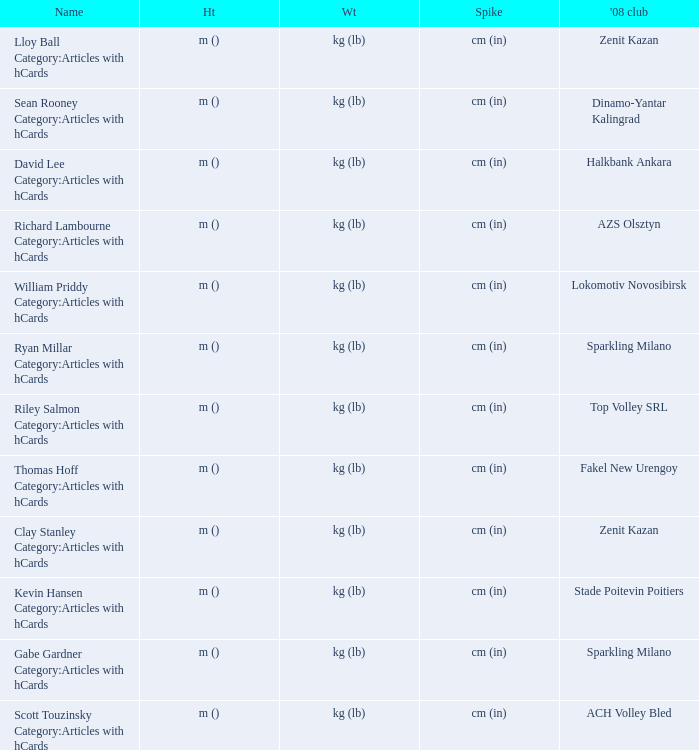What shows for height for the 2008 club of Stade Poitevin Poitiers? M (). 